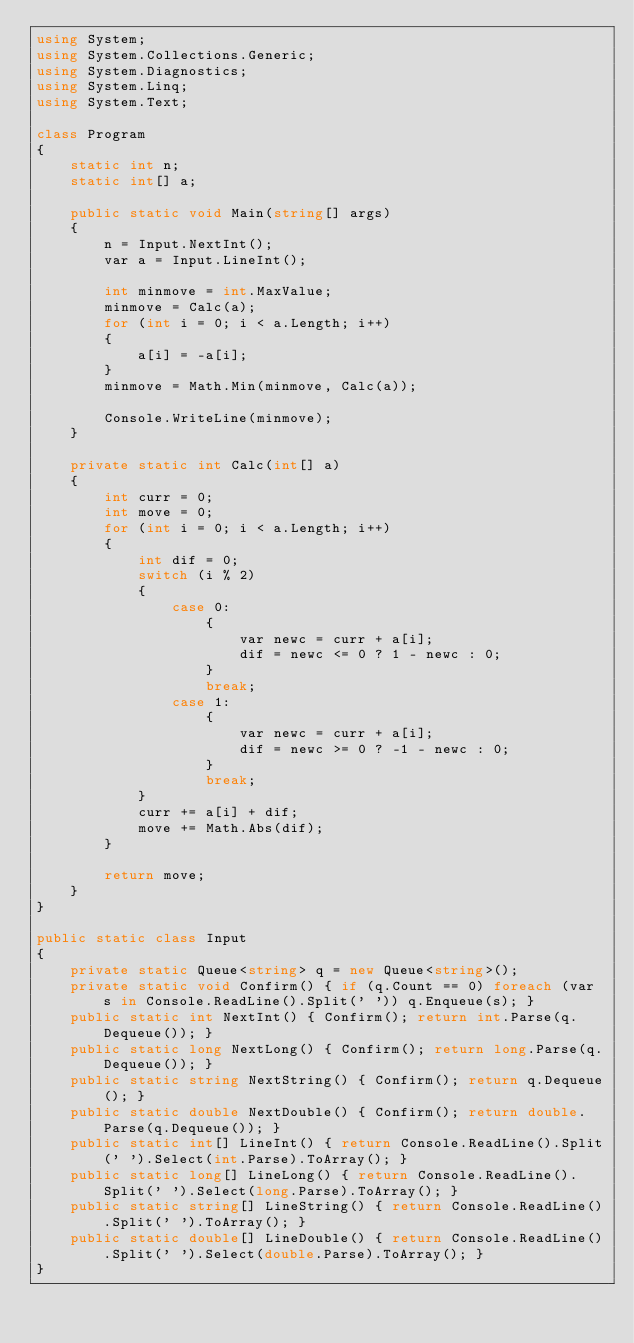Convert code to text. <code><loc_0><loc_0><loc_500><loc_500><_C#_>using System;
using System.Collections.Generic;
using System.Diagnostics;
using System.Linq;
using System.Text;

class Program
{
    static int n;
    static int[] a;

    public static void Main(string[] args)
    {
        n = Input.NextInt();
        var a = Input.LineInt();

        int minmove = int.MaxValue;
        minmove = Calc(a);
        for (int i = 0; i < a.Length; i++)
        {
            a[i] = -a[i];
        }
        minmove = Math.Min(minmove, Calc(a));

        Console.WriteLine(minmove);
    }

    private static int Calc(int[] a)
    {
        int curr = 0;
        int move = 0;
        for (int i = 0; i < a.Length; i++)
        {
            int dif = 0;
            switch (i % 2)
            {
                case 0:
                    {
                        var newc = curr + a[i];
                        dif = newc <= 0 ? 1 - newc : 0;
                    }
                    break;
                case 1:
                    {
                        var newc = curr + a[i];
                        dif = newc >= 0 ? -1 - newc : 0;
                    }
                    break;
            }
            curr += a[i] + dif;
            move += Math.Abs(dif);
        }

        return move;
    }
}

public static class Input
{
    private static Queue<string> q = new Queue<string>();
    private static void Confirm() { if (q.Count == 0) foreach (var s in Console.ReadLine().Split(' ')) q.Enqueue(s); }
    public static int NextInt() { Confirm(); return int.Parse(q.Dequeue()); }
    public static long NextLong() { Confirm(); return long.Parse(q.Dequeue()); }
    public static string NextString() { Confirm(); return q.Dequeue(); }
    public static double NextDouble() { Confirm(); return double.Parse(q.Dequeue()); }
    public static int[] LineInt() { return Console.ReadLine().Split(' ').Select(int.Parse).ToArray(); }
    public static long[] LineLong() { return Console.ReadLine().Split(' ').Select(long.Parse).ToArray(); }
    public static string[] LineString() { return Console.ReadLine().Split(' ').ToArray(); }
    public static double[] LineDouble() { return Console.ReadLine().Split(' ').Select(double.Parse).ToArray(); }
}
</code> 